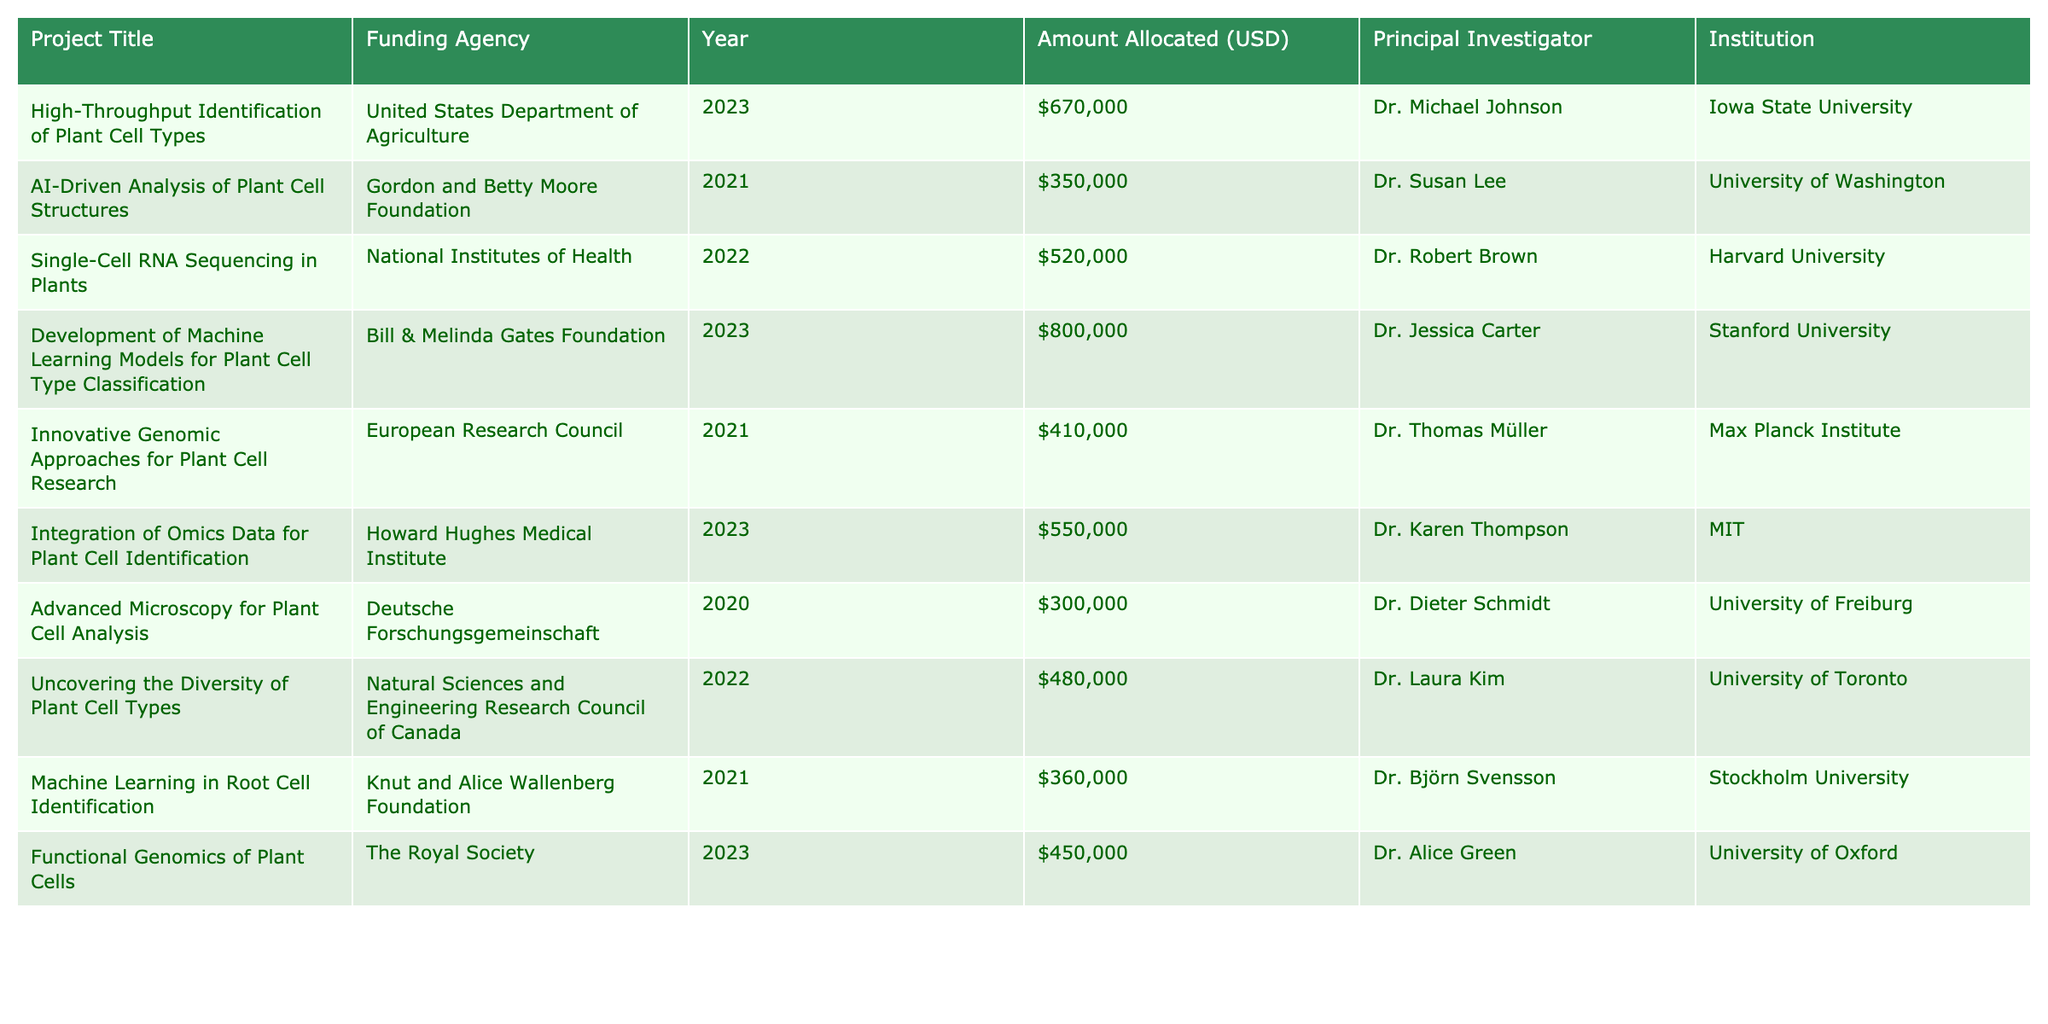What is the total amount allocated for projects in 2023? To find the total amount allocated for projects in 2023, I will look at the "Amount Allocated (USD)" column for the rows where "Year" is 2023. The projects and their allocations are: $670,000 (High-Throughput Identification of Plant Cell Types), $800,000 (Development of Machine Learning Models for Plant Cell Type Classification), $550,000 (Integration of Omics Data for Plant Cell Identification), and $450,000 (Functional Genomics of Plant Cells). Summing these amounts gives: 670000 + 800000 + 550000 + 450000 = 2470000.
Answer: 2470000 Which funding agency allocated the highest amount for a single project? To find the funding agency with the highest allocation, I will check the "Amount Allocated (USD)" column for each project and identify the maximum value. The highest amount allocated is $800,000 for the project "Development of Machine Learning Models for Plant Cell Type Classification" by the Bill & Melinda Gates Foundation.
Answer: Bill & Melinda Gates Foundation Did any projects receive funding from the National Institutes of Health? By scanning the "Funding Agency" column, I find that the project "Single-Cell RNA Sequencing in Plants," which received $520,000, is funded by the National Institutes of Health. Therefore, the answer is yes.
Answer: Yes What is the average funding amount across all projects listed? To calculate the average funding amount, I first sum all the allocations from the "Amount Allocated (USD)" column. The amounts are: $670,000, $350,000, $520,000, $800,000, $410,000, $550,000, $300,000, $480,000, $360,000, and $450,000. Adding these gives a total of $4,090,000. There are 10 projects, so the average is $4,090,000 / 10 = $409,000.
Answer: 409000 Which institution received the least funding for a project? I will look through the "Amount Allocated (USD)" column to find the smallest value. The lowest amount is $300,000 for the project "Advanced Microscopy for Plant Cell Analysis" at the University of Freiburg, indicating that this is the least funded project.
Answer: University of Freiburg 